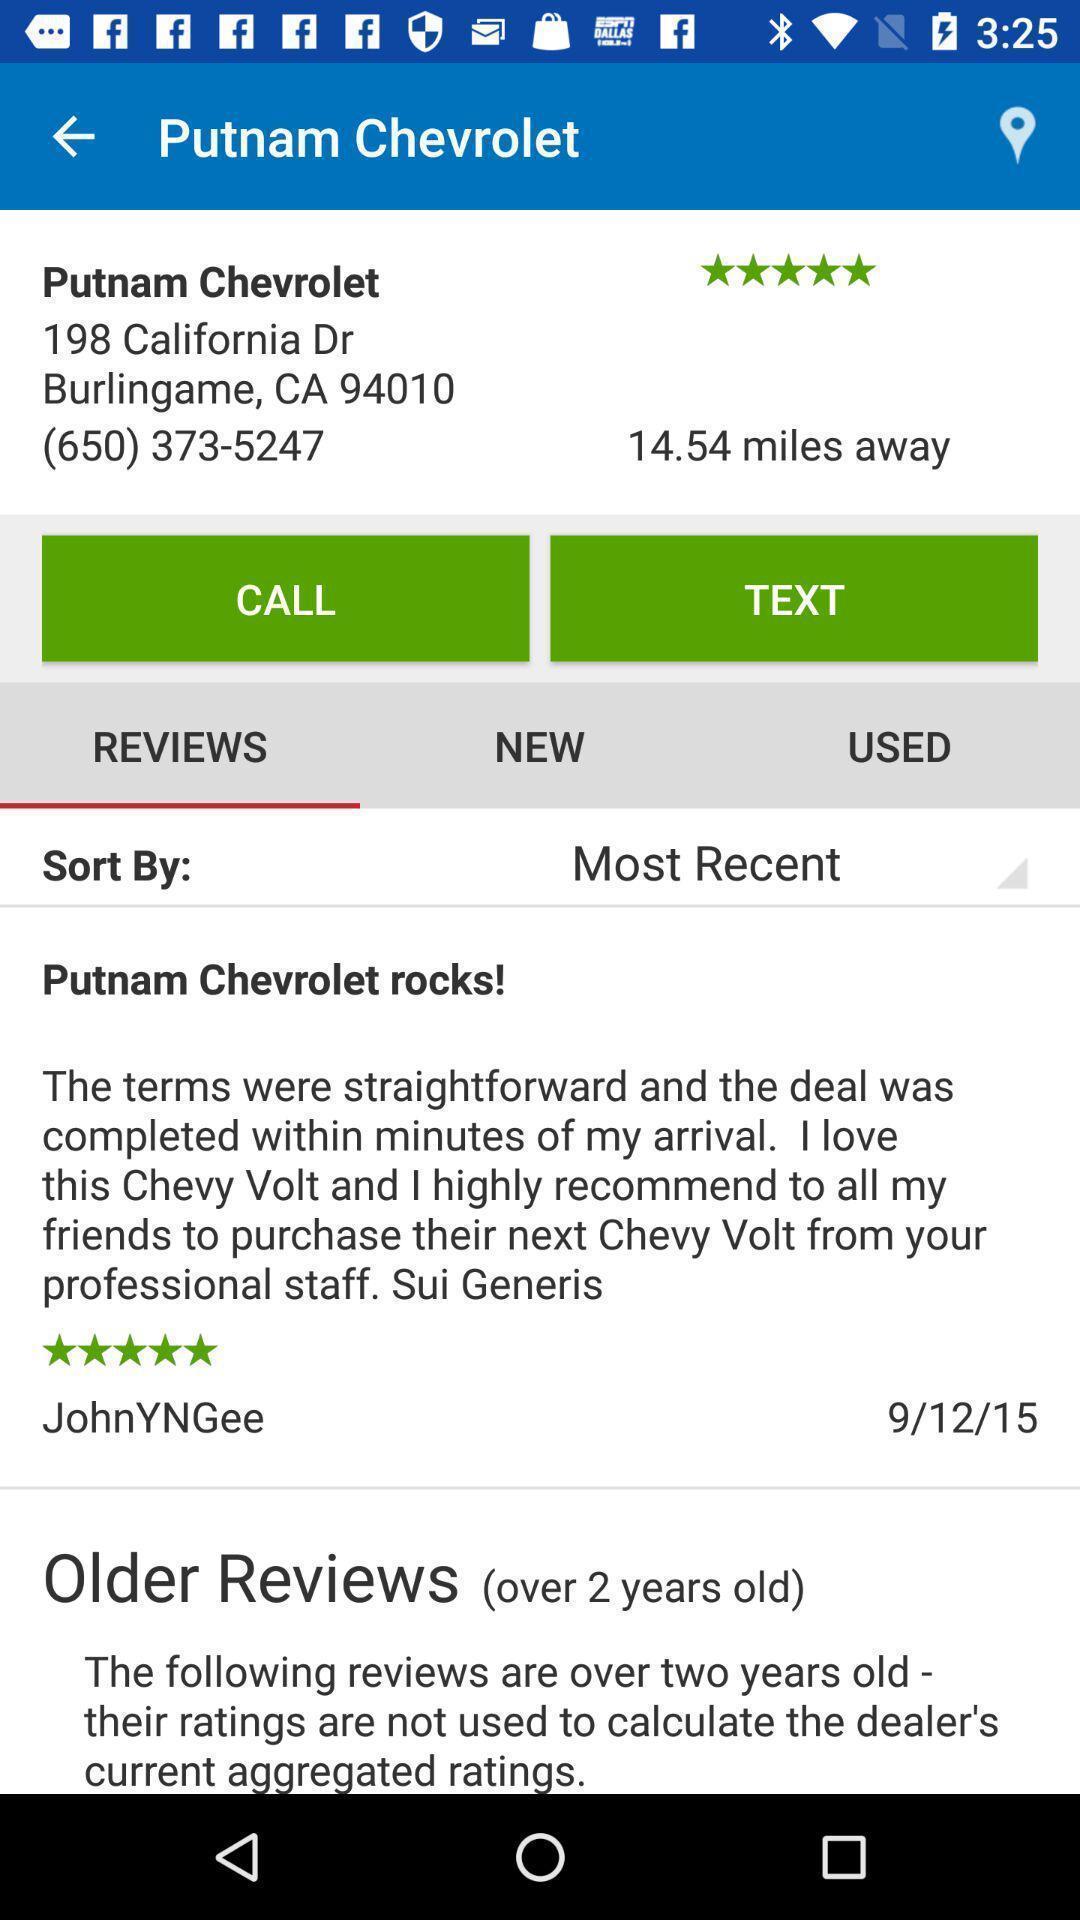Give me a summary of this screen capture. Screen page dispalying various details with reviews. 